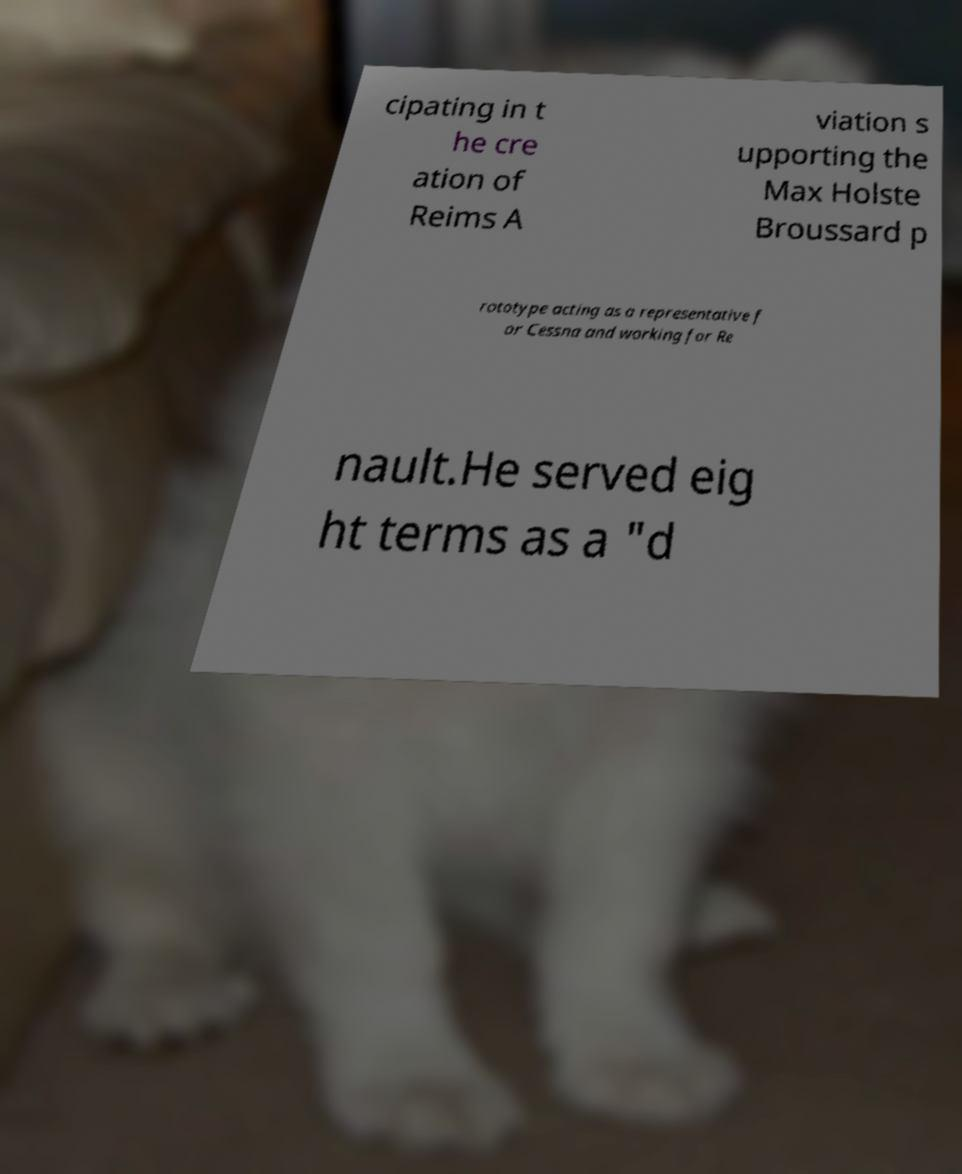For documentation purposes, I need the text within this image transcribed. Could you provide that? cipating in t he cre ation of Reims A viation s upporting the Max Holste Broussard p rototype acting as a representative f or Cessna and working for Re nault.He served eig ht terms as a "d 